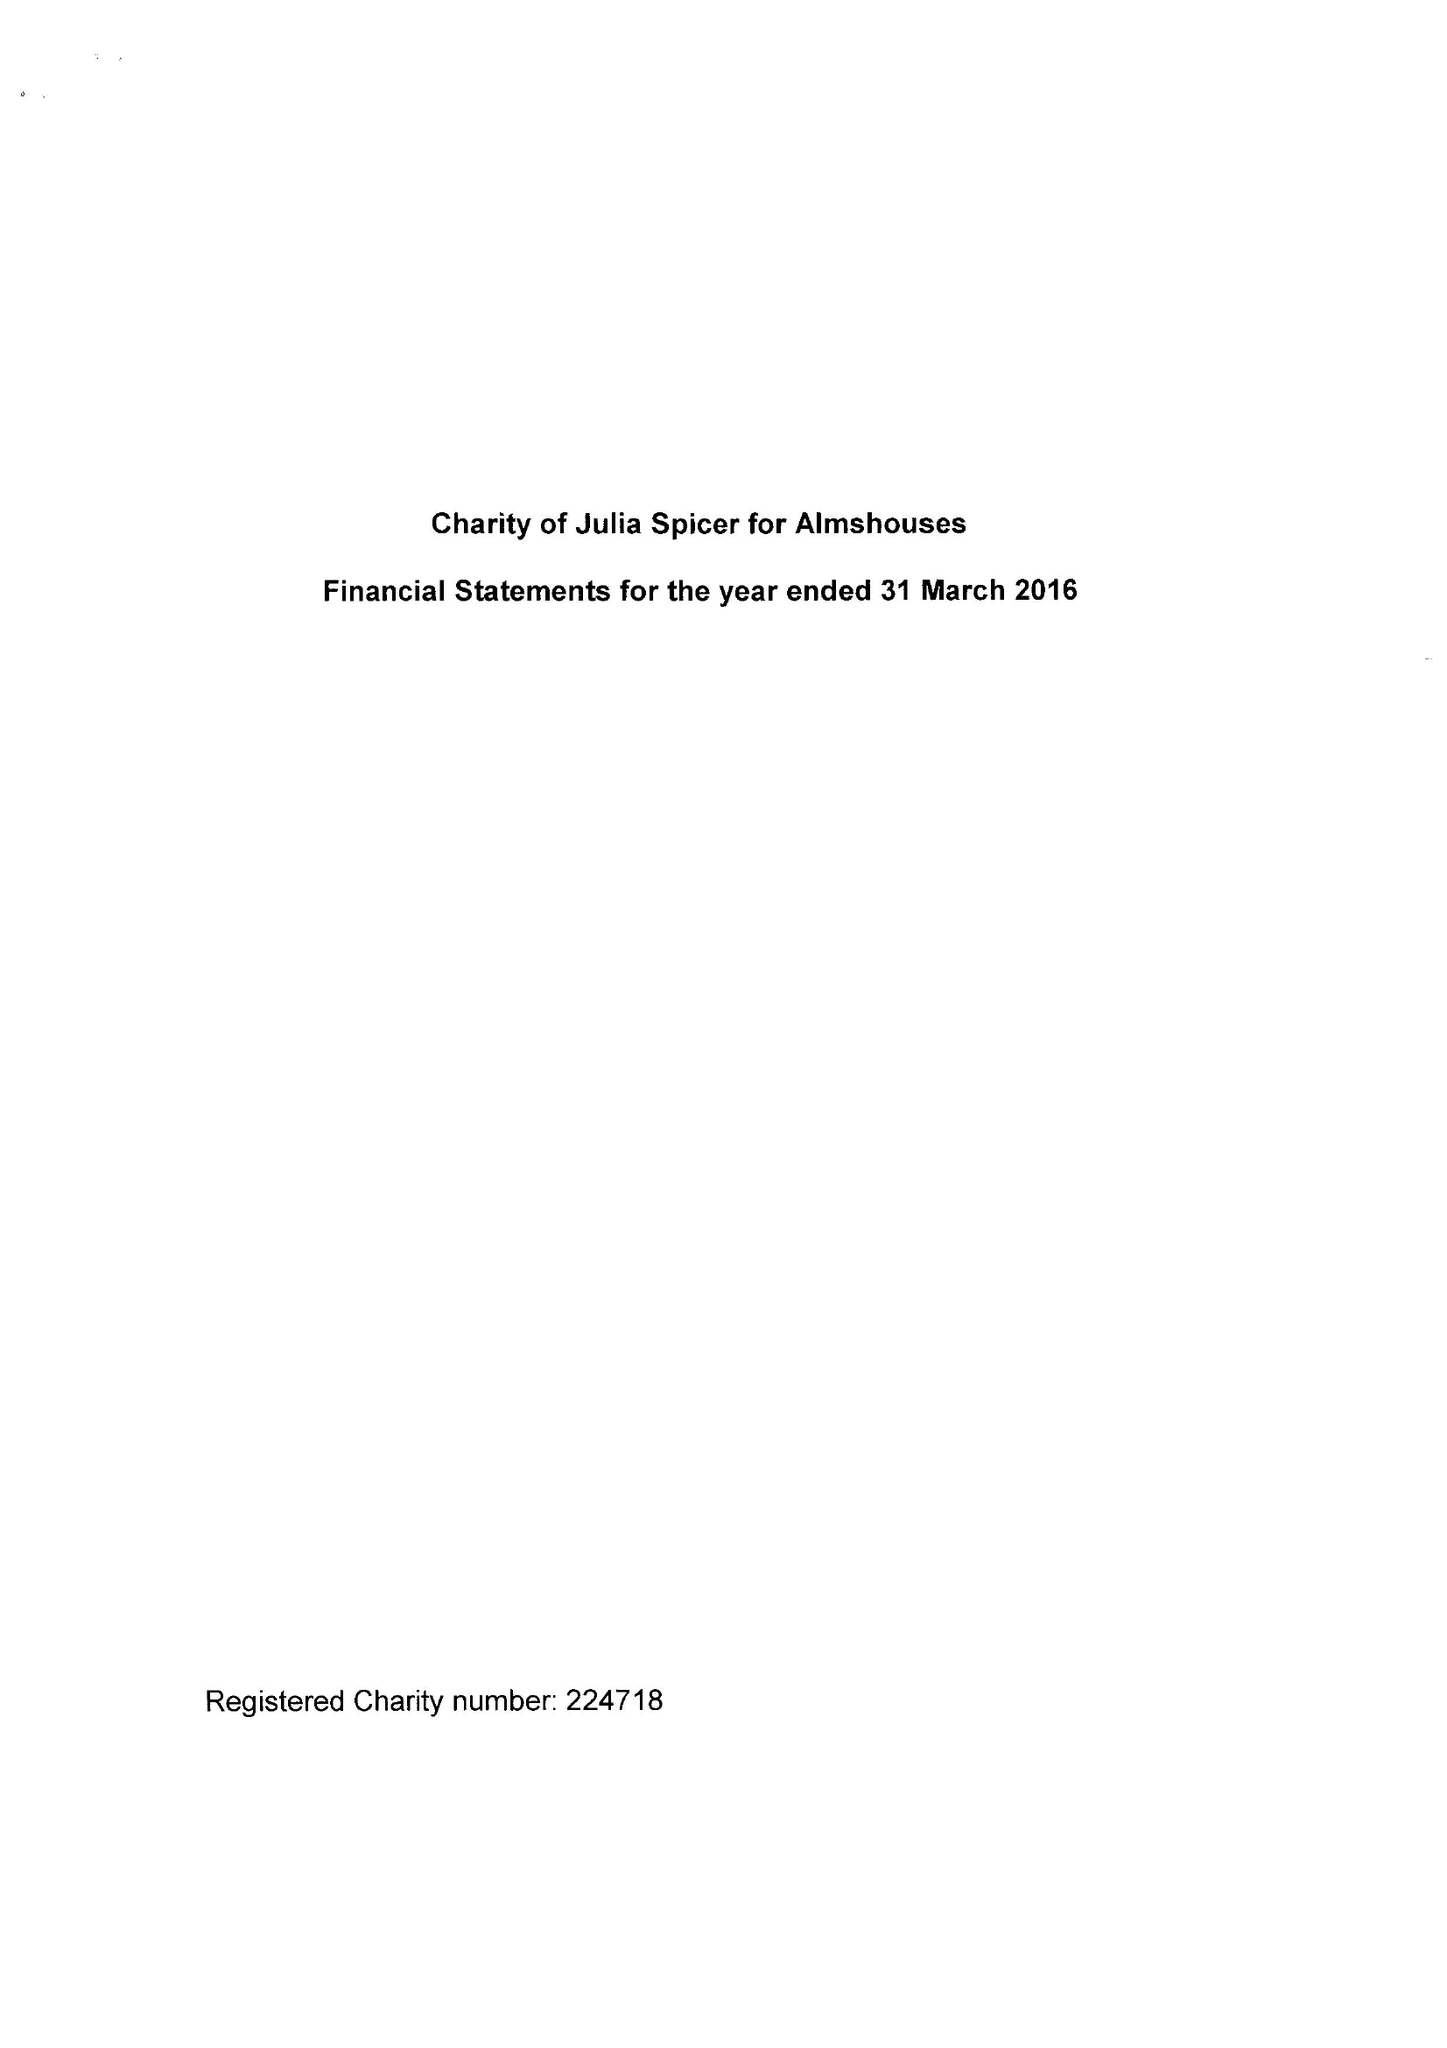What is the value for the spending_annually_in_british_pounds?
Answer the question using a single word or phrase. 29725.00 